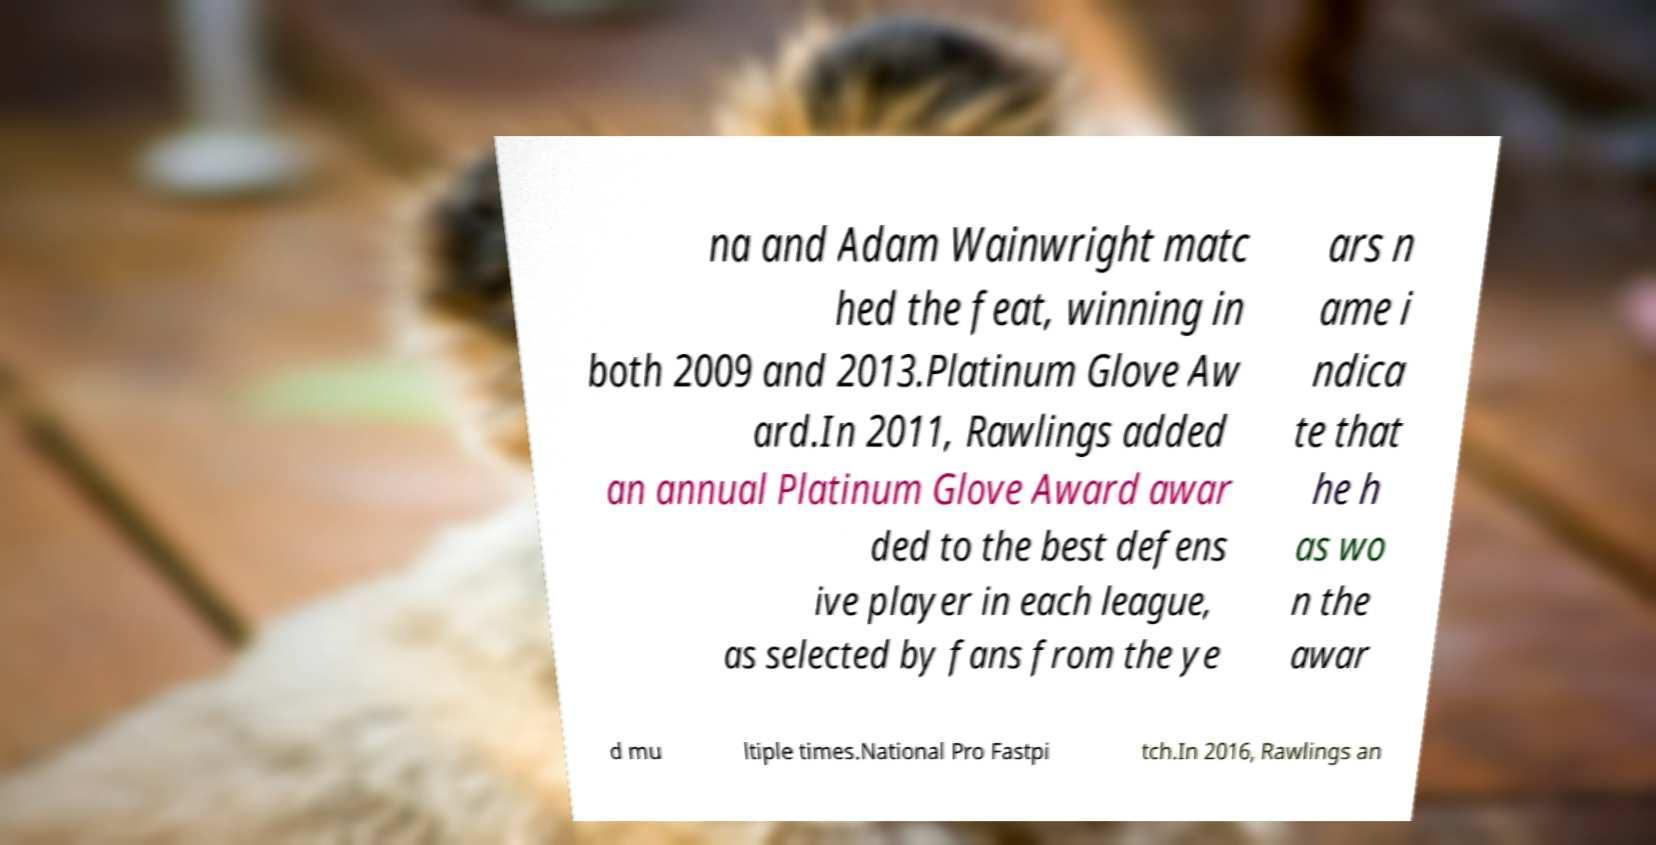For documentation purposes, I need the text within this image transcribed. Could you provide that? na and Adam Wainwright matc hed the feat, winning in both 2009 and 2013.Platinum Glove Aw ard.In 2011, Rawlings added an annual Platinum Glove Award awar ded to the best defens ive player in each league, as selected by fans from the ye ars n ame i ndica te that he h as wo n the awar d mu ltiple times.National Pro Fastpi tch.In 2016, Rawlings an 